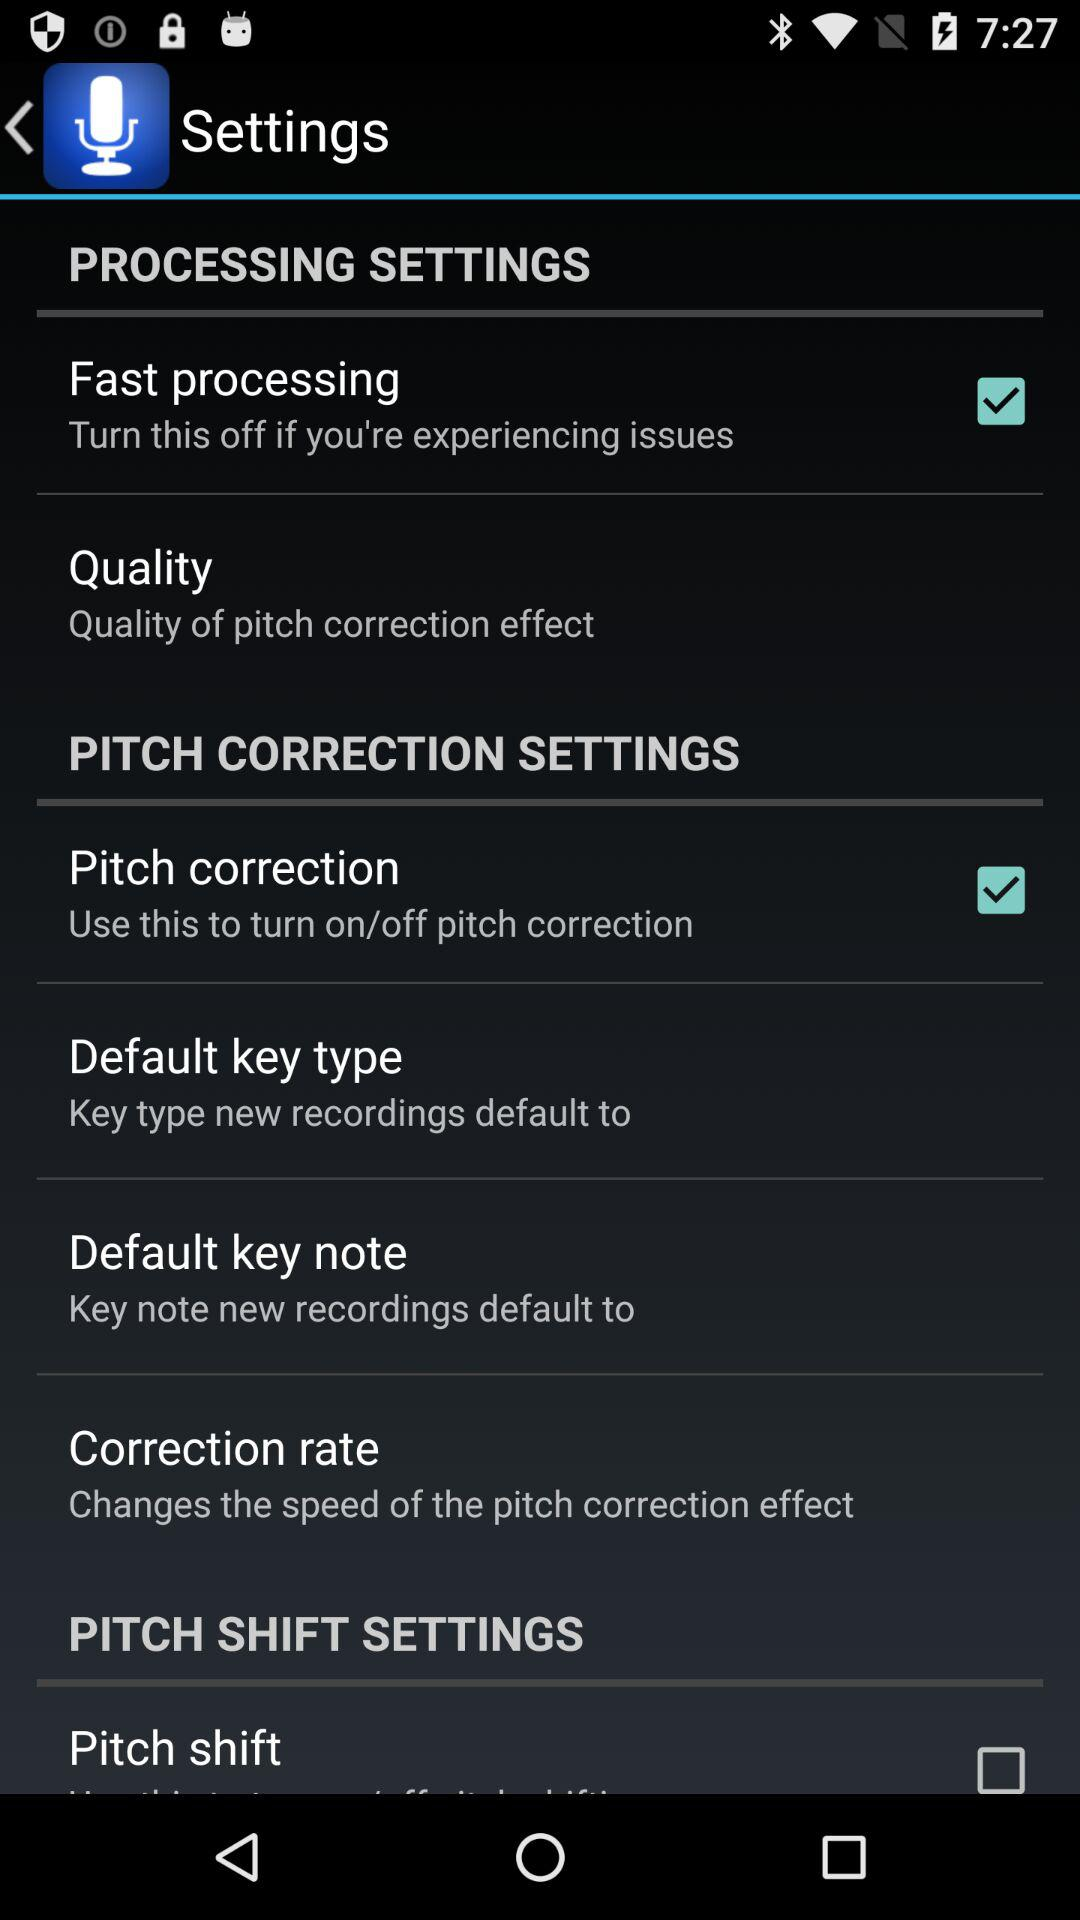What is the checked option in the pitch correction settings? The checked option in the pitch correction settings is "Pitch correction". 